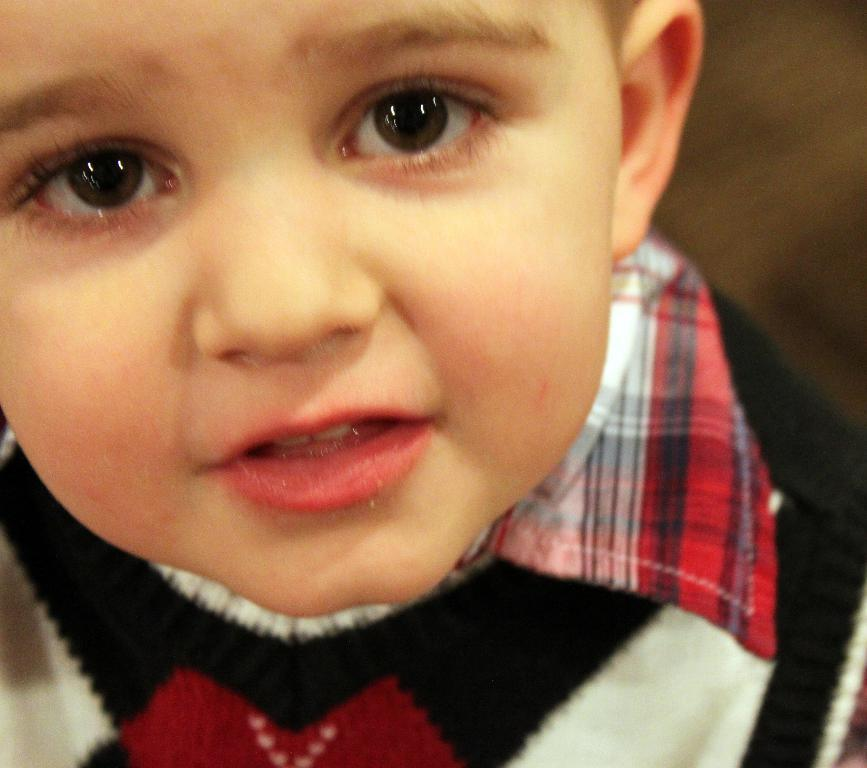What is the gender of the child in the image? There is a baby boy in the image. What type of clothing is the baby boy wearing? The baby boy is wearing a sweater and a shirt. What is the baby boy doing in the image? The baby boy is watching something. What type of twig is the baby boy holding in the image? There is no twig present in the image. What type of net is being used to catch the baby boy in the image? There is no net present in the image, and the baby boy is not being caught. 